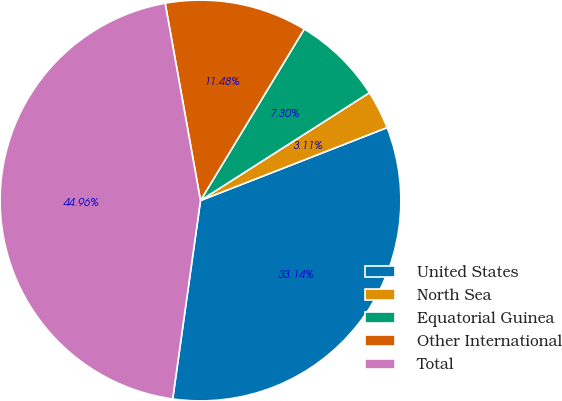Convert chart to OTSL. <chart><loc_0><loc_0><loc_500><loc_500><pie_chart><fcel>United States<fcel>North Sea<fcel>Equatorial Guinea<fcel>Other International<fcel>Total<nl><fcel>33.14%<fcel>3.11%<fcel>7.3%<fcel>11.48%<fcel>44.96%<nl></chart> 